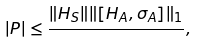Convert formula to latex. <formula><loc_0><loc_0><loc_500><loc_500>| P | \leq \frac { \| H _ { S } \| \| [ H _ { A } , \sigma _ { A } ] \| _ { 1 } } { } ,</formula> 